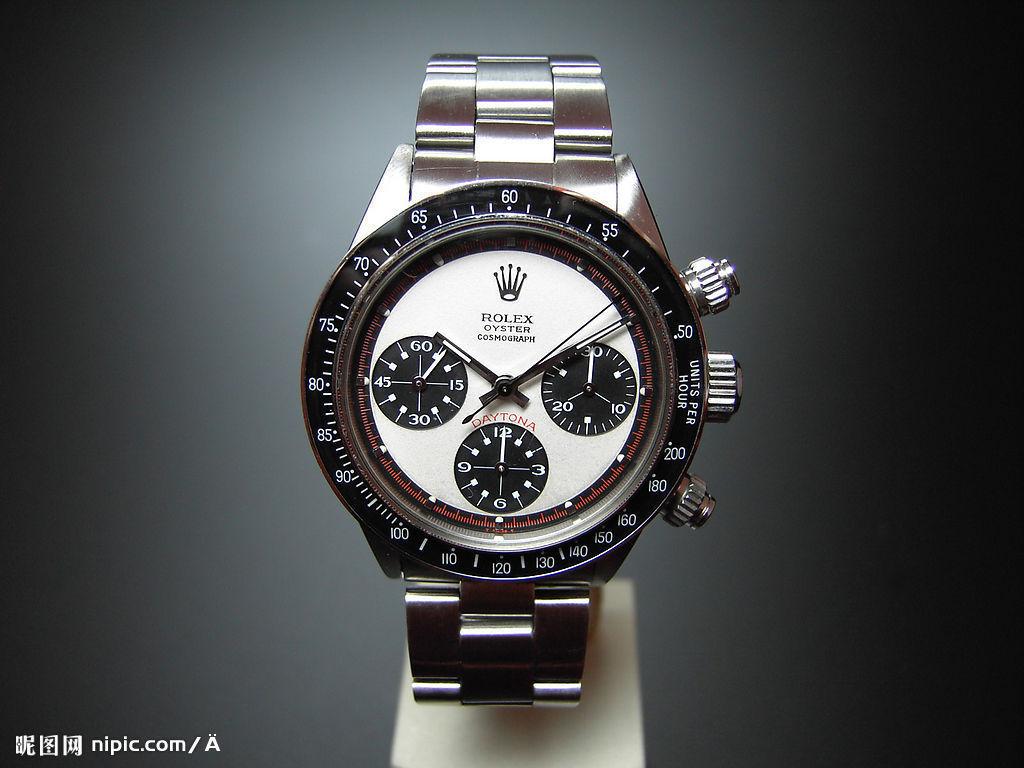What is the url in the add?
Offer a terse response. Nipic.com. What brand is this watch?
Your answer should be compact. Rolex. 